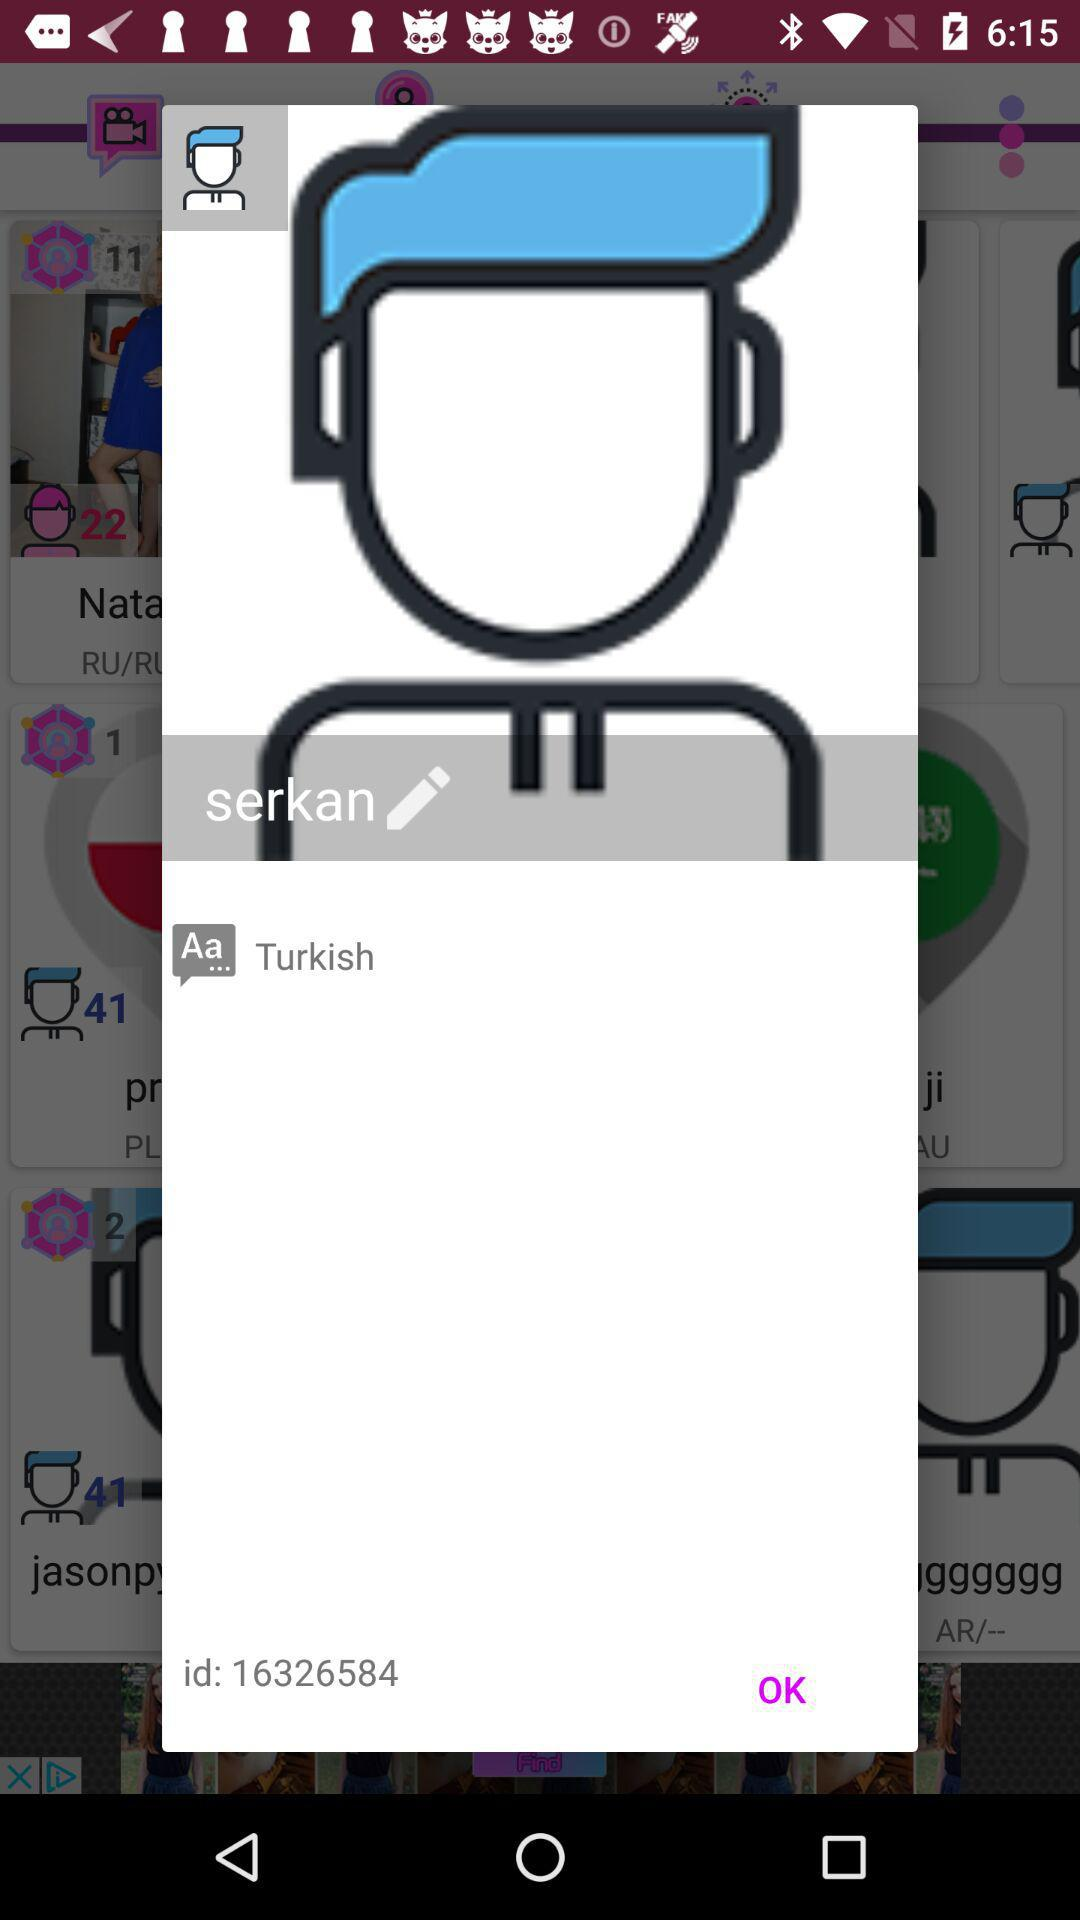How old is the user?
When the provided information is insufficient, respond with <no answer>. <no answer> 